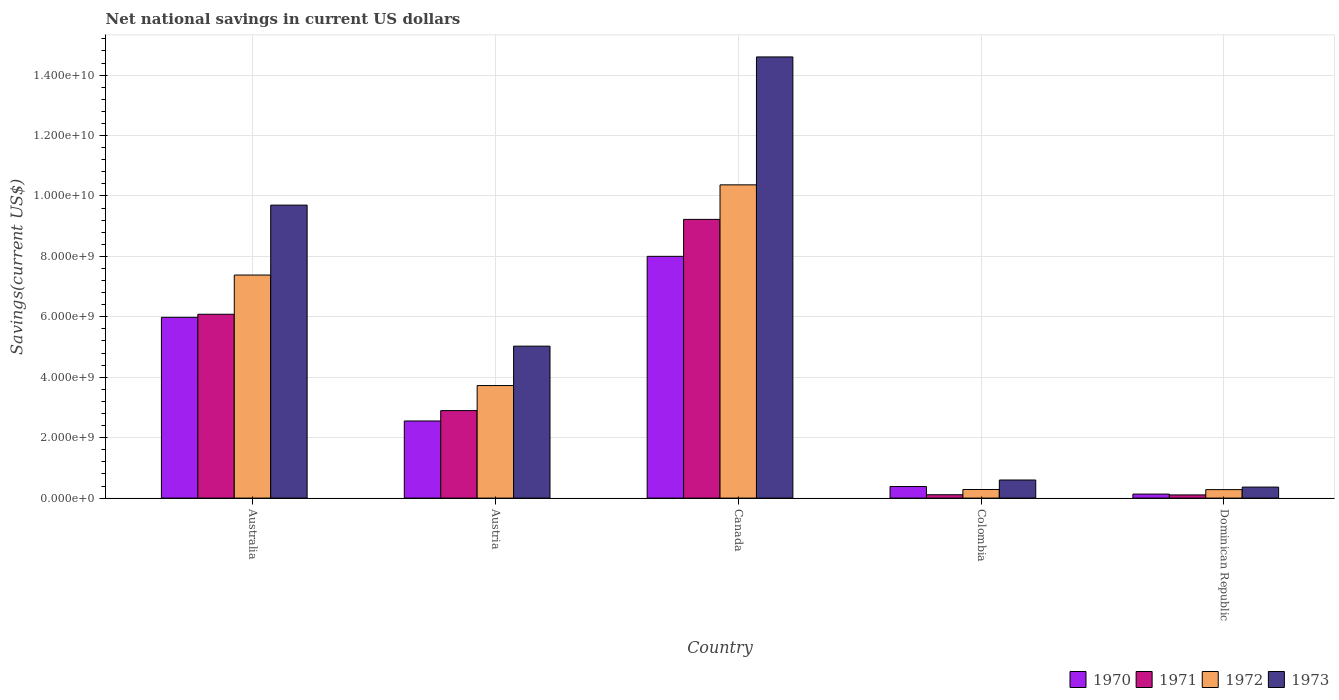How many bars are there on the 1st tick from the right?
Offer a very short reply. 4. What is the label of the 5th group of bars from the left?
Provide a short and direct response. Dominican Republic. What is the net national savings in 1970 in Colombia?
Your answer should be very brief. 3.83e+08. Across all countries, what is the maximum net national savings in 1972?
Give a very brief answer. 1.04e+1. Across all countries, what is the minimum net national savings in 1972?
Keep it short and to the point. 2.80e+08. In which country was the net national savings in 1973 maximum?
Your answer should be compact. Canada. In which country was the net national savings in 1973 minimum?
Make the answer very short. Dominican Republic. What is the total net national savings in 1972 in the graph?
Provide a succinct answer. 2.20e+1. What is the difference between the net national savings in 1971 in Austria and that in Colombia?
Provide a short and direct response. 2.78e+09. What is the difference between the net national savings in 1970 in Austria and the net national savings in 1973 in Dominican Republic?
Provide a succinct answer. 2.19e+09. What is the average net national savings in 1972 per country?
Your answer should be very brief. 4.41e+09. What is the difference between the net national savings of/in 1971 and net national savings of/in 1972 in Canada?
Your answer should be very brief. -1.14e+09. In how many countries, is the net national savings in 1973 greater than 1200000000 US$?
Ensure brevity in your answer.  3. What is the ratio of the net national savings in 1973 in Canada to that in Dominican Republic?
Offer a very short reply. 40.06. What is the difference between the highest and the second highest net national savings in 1971?
Make the answer very short. 3.19e+09. What is the difference between the highest and the lowest net national savings in 1972?
Your answer should be very brief. 1.01e+1. In how many countries, is the net national savings in 1971 greater than the average net national savings in 1971 taken over all countries?
Give a very brief answer. 2. What does the 4th bar from the left in Australia represents?
Your answer should be very brief. 1973. Is it the case that in every country, the sum of the net national savings in 1972 and net national savings in 1971 is greater than the net national savings in 1970?
Give a very brief answer. Yes. Are all the bars in the graph horizontal?
Offer a very short reply. No. How many countries are there in the graph?
Offer a terse response. 5. Does the graph contain any zero values?
Keep it short and to the point. No. What is the title of the graph?
Give a very brief answer. Net national savings in current US dollars. Does "2011" appear as one of the legend labels in the graph?
Ensure brevity in your answer.  No. What is the label or title of the Y-axis?
Provide a succinct answer. Savings(current US$). What is the Savings(current US$) in 1970 in Australia?
Offer a terse response. 5.98e+09. What is the Savings(current US$) in 1971 in Australia?
Your answer should be compact. 6.09e+09. What is the Savings(current US$) in 1972 in Australia?
Offer a terse response. 7.38e+09. What is the Savings(current US$) of 1973 in Australia?
Your answer should be very brief. 9.70e+09. What is the Savings(current US$) in 1970 in Austria?
Your response must be concise. 2.55e+09. What is the Savings(current US$) of 1971 in Austria?
Provide a short and direct response. 2.90e+09. What is the Savings(current US$) of 1972 in Austria?
Offer a very short reply. 3.73e+09. What is the Savings(current US$) in 1973 in Austria?
Provide a short and direct response. 5.03e+09. What is the Savings(current US$) of 1970 in Canada?
Give a very brief answer. 8.00e+09. What is the Savings(current US$) in 1971 in Canada?
Provide a short and direct response. 9.23e+09. What is the Savings(current US$) in 1972 in Canada?
Provide a succinct answer. 1.04e+1. What is the Savings(current US$) of 1973 in Canada?
Give a very brief answer. 1.46e+1. What is the Savings(current US$) in 1970 in Colombia?
Your response must be concise. 3.83e+08. What is the Savings(current US$) of 1971 in Colombia?
Offer a terse response. 1.11e+08. What is the Savings(current US$) in 1972 in Colombia?
Your answer should be very brief. 2.84e+08. What is the Savings(current US$) of 1973 in Colombia?
Give a very brief answer. 5.98e+08. What is the Savings(current US$) in 1970 in Dominican Republic?
Your answer should be compact. 1.33e+08. What is the Savings(current US$) in 1971 in Dominican Republic?
Provide a succinct answer. 1.05e+08. What is the Savings(current US$) of 1972 in Dominican Republic?
Your response must be concise. 2.80e+08. What is the Savings(current US$) of 1973 in Dominican Republic?
Your answer should be compact. 3.65e+08. Across all countries, what is the maximum Savings(current US$) in 1970?
Keep it short and to the point. 8.00e+09. Across all countries, what is the maximum Savings(current US$) in 1971?
Give a very brief answer. 9.23e+09. Across all countries, what is the maximum Savings(current US$) in 1972?
Ensure brevity in your answer.  1.04e+1. Across all countries, what is the maximum Savings(current US$) in 1973?
Your response must be concise. 1.46e+1. Across all countries, what is the minimum Savings(current US$) in 1970?
Offer a very short reply. 1.33e+08. Across all countries, what is the minimum Savings(current US$) in 1971?
Your response must be concise. 1.05e+08. Across all countries, what is the minimum Savings(current US$) of 1972?
Offer a very short reply. 2.80e+08. Across all countries, what is the minimum Savings(current US$) in 1973?
Offer a very short reply. 3.65e+08. What is the total Savings(current US$) in 1970 in the graph?
Offer a terse response. 1.71e+1. What is the total Savings(current US$) of 1971 in the graph?
Give a very brief answer. 1.84e+1. What is the total Savings(current US$) of 1972 in the graph?
Provide a short and direct response. 2.20e+1. What is the total Savings(current US$) in 1973 in the graph?
Your response must be concise. 3.03e+1. What is the difference between the Savings(current US$) in 1970 in Australia and that in Austria?
Provide a succinct answer. 3.43e+09. What is the difference between the Savings(current US$) of 1971 in Australia and that in Austria?
Give a very brief answer. 3.19e+09. What is the difference between the Savings(current US$) in 1972 in Australia and that in Austria?
Your answer should be compact. 3.66e+09. What is the difference between the Savings(current US$) in 1973 in Australia and that in Austria?
Offer a very short reply. 4.67e+09. What is the difference between the Savings(current US$) in 1970 in Australia and that in Canada?
Make the answer very short. -2.02e+09. What is the difference between the Savings(current US$) of 1971 in Australia and that in Canada?
Ensure brevity in your answer.  -3.14e+09. What is the difference between the Savings(current US$) in 1972 in Australia and that in Canada?
Offer a very short reply. -2.99e+09. What is the difference between the Savings(current US$) in 1973 in Australia and that in Canada?
Give a very brief answer. -4.90e+09. What is the difference between the Savings(current US$) of 1970 in Australia and that in Colombia?
Offer a very short reply. 5.60e+09. What is the difference between the Savings(current US$) of 1971 in Australia and that in Colombia?
Your response must be concise. 5.97e+09. What is the difference between the Savings(current US$) in 1972 in Australia and that in Colombia?
Make the answer very short. 7.10e+09. What is the difference between the Savings(current US$) of 1973 in Australia and that in Colombia?
Provide a succinct answer. 9.10e+09. What is the difference between the Savings(current US$) in 1970 in Australia and that in Dominican Republic?
Provide a short and direct response. 5.85e+09. What is the difference between the Savings(current US$) of 1971 in Australia and that in Dominican Republic?
Provide a short and direct response. 5.98e+09. What is the difference between the Savings(current US$) of 1972 in Australia and that in Dominican Republic?
Provide a succinct answer. 7.10e+09. What is the difference between the Savings(current US$) in 1973 in Australia and that in Dominican Republic?
Offer a very short reply. 9.33e+09. What is the difference between the Savings(current US$) of 1970 in Austria and that in Canada?
Offer a terse response. -5.45e+09. What is the difference between the Savings(current US$) of 1971 in Austria and that in Canada?
Your answer should be compact. -6.33e+09. What is the difference between the Savings(current US$) of 1972 in Austria and that in Canada?
Provide a succinct answer. -6.64e+09. What is the difference between the Savings(current US$) of 1973 in Austria and that in Canada?
Ensure brevity in your answer.  -9.57e+09. What is the difference between the Savings(current US$) of 1970 in Austria and that in Colombia?
Make the answer very short. 2.17e+09. What is the difference between the Savings(current US$) in 1971 in Austria and that in Colombia?
Provide a succinct answer. 2.78e+09. What is the difference between the Savings(current US$) of 1972 in Austria and that in Colombia?
Your response must be concise. 3.44e+09. What is the difference between the Savings(current US$) in 1973 in Austria and that in Colombia?
Your answer should be compact. 4.43e+09. What is the difference between the Savings(current US$) in 1970 in Austria and that in Dominican Republic?
Offer a very short reply. 2.42e+09. What is the difference between the Savings(current US$) in 1971 in Austria and that in Dominican Republic?
Ensure brevity in your answer.  2.79e+09. What is the difference between the Savings(current US$) of 1972 in Austria and that in Dominican Republic?
Your answer should be very brief. 3.44e+09. What is the difference between the Savings(current US$) of 1973 in Austria and that in Dominican Republic?
Ensure brevity in your answer.  4.66e+09. What is the difference between the Savings(current US$) of 1970 in Canada and that in Colombia?
Your response must be concise. 7.62e+09. What is the difference between the Savings(current US$) of 1971 in Canada and that in Colombia?
Provide a succinct answer. 9.11e+09. What is the difference between the Savings(current US$) in 1972 in Canada and that in Colombia?
Your answer should be compact. 1.01e+1. What is the difference between the Savings(current US$) of 1973 in Canada and that in Colombia?
Make the answer very short. 1.40e+1. What is the difference between the Savings(current US$) of 1970 in Canada and that in Dominican Republic?
Your answer should be compact. 7.87e+09. What is the difference between the Savings(current US$) in 1971 in Canada and that in Dominican Republic?
Provide a succinct answer. 9.12e+09. What is the difference between the Savings(current US$) in 1972 in Canada and that in Dominican Republic?
Offer a terse response. 1.01e+1. What is the difference between the Savings(current US$) of 1973 in Canada and that in Dominican Republic?
Make the answer very short. 1.42e+1. What is the difference between the Savings(current US$) in 1970 in Colombia and that in Dominican Republic?
Offer a terse response. 2.50e+08. What is the difference between the Savings(current US$) of 1971 in Colombia and that in Dominican Republic?
Your answer should be compact. 6.03e+06. What is the difference between the Savings(current US$) of 1972 in Colombia and that in Dominican Republic?
Give a very brief answer. 3.48e+06. What is the difference between the Savings(current US$) of 1973 in Colombia and that in Dominican Republic?
Make the answer very short. 2.34e+08. What is the difference between the Savings(current US$) in 1970 in Australia and the Savings(current US$) in 1971 in Austria?
Offer a terse response. 3.09e+09. What is the difference between the Savings(current US$) of 1970 in Australia and the Savings(current US$) of 1972 in Austria?
Your response must be concise. 2.26e+09. What is the difference between the Savings(current US$) of 1970 in Australia and the Savings(current US$) of 1973 in Austria?
Give a very brief answer. 9.54e+08. What is the difference between the Savings(current US$) in 1971 in Australia and the Savings(current US$) in 1972 in Austria?
Your answer should be very brief. 2.36e+09. What is the difference between the Savings(current US$) of 1971 in Australia and the Savings(current US$) of 1973 in Austria?
Ensure brevity in your answer.  1.06e+09. What is the difference between the Savings(current US$) in 1972 in Australia and the Savings(current US$) in 1973 in Austria?
Your answer should be compact. 2.35e+09. What is the difference between the Savings(current US$) of 1970 in Australia and the Savings(current US$) of 1971 in Canada?
Your answer should be compact. -3.24e+09. What is the difference between the Savings(current US$) in 1970 in Australia and the Savings(current US$) in 1972 in Canada?
Keep it short and to the point. -4.38e+09. What is the difference between the Savings(current US$) in 1970 in Australia and the Savings(current US$) in 1973 in Canada?
Ensure brevity in your answer.  -8.62e+09. What is the difference between the Savings(current US$) of 1971 in Australia and the Savings(current US$) of 1972 in Canada?
Provide a short and direct response. -4.28e+09. What is the difference between the Savings(current US$) in 1971 in Australia and the Savings(current US$) in 1973 in Canada?
Your answer should be very brief. -8.52e+09. What is the difference between the Savings(current US$) of 1972 in Australia and the Savings(current US$) of 1973 in Canada?
Your answer should be very brief. -7.22e+09. What is the difference between the Savings(current US$) of 1970 in Australia and the Savings(current US$) of 1971 in Colombia?
Keep it short and to the point. 5.87e+09. What is the difference between the Savings(current US$) in 1970 in Australia and the Savings(current US$) in 1972 in Colombia?
Offer a very short reply. 5.70e+09. What is the difference between the Savings(current US$) of 1970 in Australia and the Savings(current US$) of 1973 in Colombia?
Provide a short and direct response. 5.38e+09. What is the difference between the Savings(current US$) of 1971 in Australia and the Savings(current US$) of 1972 in Colombia?
Keep it short and to the point. 5.80e+09. What is the difference between the Savings(current US$) of 1971 in Australia and the Savings(current US$) of 1973 in Colombia?
Your answer should be very brief. 5.49e+09. What is the difference between the Savings(current US$) of 1972 in Australia and the Savings(current US$) of 1973 in Colombia?
Your response must be concise. 6.78e+09. What is the difference between the Savings(current US$) in 1970 in Australia and the Savings(current US$) in 1971 in Dominican Republic?
Provide a short and direct response. 5.88e+09. What is the difference between the Savings(current US$) in 1970 in Australia and the Savings(current US$) in 1972 in Dominican Republic?
Provide a succinct answer. 5.70e+09. What is the difference between the Savings(current US$) in 1970 in Australia and the Savings(current US$) in 1973 in Dominican Republic?
Keep it short and to the point. 5.62e+09. What is the difference between the Savings(current US$) in 1971 in Australia and the Savings(current US$) in 1972 in Dominican Republic?
Make the answer very short. 5.80e+09. What is the difference between the Savings(current US$) in 1971 in Australia and the Savings(current US$) in 1973 in Dominican Republic?
Your response must be concise. 5.72e+09. What is the difference between the Savings(current US$) of 1972 in Australia and the Savings(current US$) of 1973 in Dominican Republic?
Provide a succinct answer. 7.02e+09. What is the difference between the Savings(current US$) of 1970 in Austria and the Savings(current US$) of 1971 in Canada?
Your answer should be compact. -6.67e+09. What is the difference between the Savings(current US$) of 1970 in Austria and the Savings(current US$) of 1972 in Canada?
Give a very brief answer. -7.82e+09. What is the difference between the Savings(current US$) of 1970 in Austria and the Savings(current US$) of 1973 in Canada?
Provide a short and direct response. -1.20e+1. What is the difference between the Savings(current US$) of 1971 in Austria and the Savings(current US$) of 1972 in Canada?
Provide a short and direct response. -7.47e+09. What is the difference between the Savings(current US$) of 1971 in Austria and the Savings(current US$) of 1973 in Canada?
Make the answer very short. -1.17e+1. What is the difference between the Savings(current US$) in 1972 in Austria and the Savings(current US$) in 1973 in Canada?
Your answer should be compact. -1.09e+1. What is the difference between the Savings(current US$) of 1970 in Austria and the Savings(current US$) of 1971 in Colombia?
Make the answer very short. 2.44e+09. What is the difference between the Savings(current US$) of 1970 in Austria and the Savings(current US$) of 1972 in Colombia?
Your response must be concise. 2.27e+09. What is the difference between the Savings(current US$) of 1970 in Austria and the Savings(current US$) of 1973 in Colombia?
Ensure brevity in your answer.  1.95e+09. What is the difference between the Savings(current US$) of 1971 in Austria and the Savings(current US$) of 1972 in Colombia?
Your answer should be compact. 2.61e+09. What is the difference between the Savings(current US$) of 1971 in Austria and the Savings(current US$) of 1973 in Colombia?
Provide a short and direct response. 2.30e+09. What is the difference between the Savings(current US$) of 1972 in Austria and the Savings(current US$) of 1973 in Colombia?
Give a very brief answer. 3.13e+09. What is the difference between the Savings(current US$) of 1970 in Austria and the Savings(current US$) of 1971 in Dominican Republic?
Keep it short and to the point. 2.45e+09. What is the difference between the Savings(current US$) in 1970 in Austria and the Savings(current US$) in 1972 in Dominican Republic?
Ensure brevity in your answer.  2.27e+09. What is the difference between the Savings(current US$) in 1970 in Austria and the Savings(current US$) in 1973 in Dominican Republic?
Ensure brevity in your answer.  2.19e+09. What is the difference between the Savings(current US$) of 1971 in Austria and the Savings(current US$) of 1972 in Dominican Republic?
Your response must be concise. 2.62e+09. What is the difference between the Savings(current US$) of 1971 in Austria and the Savings(current US$) of 1973 in Dominican Republic?
Give a very brief answer. 2.53e+09. What is the difference between the Savings(current US$) of 1972 in Austria and the Savings(current US$) of 1973 in Dominican Republic?
Give a very brief answer. 3.36e+09. What is the difference between the Savings(current US$) in 1970 in Canada and the Savings(current US$) in 1971 in Colombia?
Offer a very short reply. 7.89e+09. What is the difference between the Savings(current US$) in 1970 in Canada and the Savings(current US$) in 1972 in Colombia?
Offer a very short reply. 7.72e+09. What is the difference between the Savings(current US$) of 1970 in Canada and the Savings(current US$) of 1973 in Colombia?
Your answer should be compact. 7.40e+09. What is the difference between the Savings(current US$) in 1971 in Canada and the Savings(current US$) in 1972 in Colombia?
Offer a terse response. 8.94e+09. What is the difference between the Savings(current US$) of 1971 in Canada and the Savings(current US$) of 1973 in Colombia?
Offer a very short reply. 8.63e+09. What is the difference between the Savings(current US$) in 1972 in Canada and the Savings(current US$) in 1973 in Colombia?
Provide a short and direct response. 9.77e+09. What is the difference between the Savings(current US$) in 1970 in Canada and the Savings(current US$) in 1971 in Dominican Republic?
Make the answer very short. 7.90e+09. What is the difference between the Savings(current US$) in 1970 in Canada and the Savings(current US$) in 1972 in Dominican Republic?
Your response must be concise. 7.72e+09. What is the difference between the Savings(current US$) of 1970 in Canada and the Savings(current US$) of 1973 in Dominican Republic?
Make the answer very short. 7.64e+09. What is the difference between the Savings(current US$) of 1971 in Canada and the Savings(current US$) of 1972 in Dominican Republic?
Give a very brief answer. 8.94e+09. What is the difference between the Savings(current US$) of 1971 in Canada and the Savings(current US$) of 1973 in Dominican Republic?
Give a very brief answer. 8.86e+09. What is the difference between the Savings(current US$) in 1972 in Canada and the Savings(current US$) in 1973 in Dominican Republic?
Give a very brief answer. 1.00e+1. What is the difference between the Savings(current US$) in 1970 in Colombia and the Savings(current US$) in 1971 in Dominican Republic?
Ensure brevity in your answer.  2.77e+08. What is the difference between the Savings(current US$) in 1970 in Colombia and the Savings(current US$) in 1972 in Dominican Republic?
Give a very brief answer. 1.02e+08. What is the difference between the Savings(current US$) of 1970 in Colombia and the Savings(current US$) of 1973 in Dominican Republic?
Ensure brevity in your answer.  1.82e+07. What is the difference between the Savings(current US$) of 1971 in Colombia and the Savings(current US$) of 1972 in Dominican Republic?
Provide a succinct answer. -1.69e+08. What is the difference between the Savings(current US$) of 1971 in Colombia and the Savings(current US$) of 1973 in Dominican Republic?
Your answer should be very brief. -2.53e+08. What is the difference between the Savings(current US$) of 1972 in Colombia and the Savings(current US$) of 1973 in Dominican Republic?
Your response must be concise. -8.05e+07. What is the average Savings(current US$) of 1970 per country?
Offer a very short reply. 3.41e+09. What is the average Savings(current US$) of 1971 per country?
Give a very brief answer. 3.68e+09. What is the average Savings(current US$) of 1972 per country?
Give a very brief answer. 4.41e+09. What is the average Savings(current US$) in 1973 per country?
Provide a succinct answer. 6.06e+09. What is the difference between the Savings(current US$) in 1970 and Savings(current US$) in 1971 in Australia?
Make the answer very short. -1.02e+08. What is the difference between the Savings(current US$) in 1970 and Savings(current US$) in 1972 in Australia?
Offer a terse response. -1.40e+09. What is the difference between the Savings(current US$) in 1970 and Savings(current US$) in 1973 in Australia?
Your response must be concise. -3.71e+09. What is the difference between the Savings(current US$) in 1971 and Savings(current US$) in 1972 in Australia?
Give a very brief answer. -1.30e+09. What is the difference between the Savings(current US$) of 1971 and Savings(current US$) of 1973 in Australia?
Your answer should be compact. -3.61e+09. What is the difference between the Savings(current US$) in 1972 and Savings(current US$) in 1973 in Australia?
Your answer should be compact. -2.31e+09. What is the difference between the Savings(current US$) in 1970 and Savings(current US$) in 1971 in Austria?
Provide a succinct answer. -3.44e+08. What is the difference between the Savings(current US$) of 1970 and Savings(current US$) of 1972 in Austria?
Your response must be concise. -1.17e+09. What is the difference between the Savings(current US$) of 1970 and Savings(current US$) of 1973 in Austria?
Provide a succinct answer. -2.48e+09. What is the difference between the Savings(current US$) in 1971 and Savings(current US$) in 1972 in Austria?
Your answer should be compact. -8.29e+08. What is the difference between the Savings(current US$) of 1971 and Savings(current US$) of 1973 in Austria?
Keep it short and to the point. -2.13e+09. What is the difference between the Savings(current US$) in 1972 and Savings(current US$) in 1973 in Austria?
Ensure brevity in your answer.  -1.30e+09. What is the difference between the Savings(current US$) in 1970 and Savings(current US$) in 1971 in Canada?
Your answer should be compact. -1.22e+09. What is the difference between the Savings(current US$) in 1970 and Savings(current US$) in 1972 in Canada?
Offer a terse response. -2.37e+09. What is the difference between the Savings(current US$) in 1970 and Savings(current US$) in 1973 in Canada?
Make the answer very short. -6.60e+09. What is the difference between the Savings(current US$) in 1971 and Savings(current US$) in 1972 in Canada?
Ensure brevity in your answer.  -1.14e+09. What is the difference between the Savings(current US$) in 1971 and Savings(current US$) in 1973 in Canada?
Offer a very short reply. -5.38e+09. What is the difference between the Savings(current US$) in 1972 and Savings(current US$) in 1973 in Canada?
Your answer should be very brief. -4.23e+09. What is the difference between the Savings(current US$) in 1970 and Savings(current US$) in 1971 in Colombia?
Provide a short and direct response. 2.71e+08. What is the difference between the Savings(current US$) in 1970 and Savings(current US$) in 1972 in Colombia?
Offer a terse response. 9.87e+07. What is the difference between the Savings(current US$) of 1970 and Savings(current US$) of 1973 in Colombia?
Your response must be concise. -2.16e+08. What is the difference between the Savings(current US$) of 1971 and Savings(current US$) of 1972 in Colombia?
Give a very brief answer. -1.73e+08. What is the difference between the Savings(current US$) of 1971 and Savings(current US$) of 1973 in Colombia?
Give a very brief answer. -4.87e+08. What is the difference between the Savings(current US$) in 1972 and Savings(current US$) in 1973 in Colombia?
Ensure brevity in your answer.  -3.14e+08. What is the difference between the Savings(current US$) of 1970 and Savings(current US$) of 1971 in Dominican Republic?
Ensure brevity in your answer.  2.74e+07. What is the difference between the Savings(current US$) of 1970 and Savings(current US$) of 1972 in Dominican Republic?
Give a very brief answer. -1.48e+08. What is the difference between the Savings(current US$) of 1970 and Savings(current US$) of 1973 in Dominican Republic?
Keep it short and to the point. -2.32e+08. What is the difference between the Savings(current US$) in 1971 and Savings(current US$) in 1972 in Dominican Republic?
Offer a terse response. -1.75e+08. What is the difference between the Savings(current US$) in 1971 and Savings(current US$) in 1973 in Dominican Republic?
Your answer should be compact. -2.59e+08. What is the difference between the Savings(current US$) of 1972 and Savings(current US$) of 1973 in Dominican Republic?
Ensure brevity in your answer.  -8.40e+07. What is the ratio of the Savings(current US$) of 1970 in Australia to that in Austria?
Ensure brevity in your answer.  2.34. What is the ratio of the Savings(current US$) in 1971 in Australia to that in Austria?
Offer a terse response. 2.1. What is the ratio of the Savings(current US$) of 1972 in Australia to that in Austria?
Ensure brevity in your answer.  1.98. What is the ratio of the Savings(current US$) in 1973 in Australia to that in Austria?
Your response must be concise. 1.93. What is the ratio of the Savings(current US$) in 1970 in Australia to that in Canada?
Ensure brevity in your answer.  0.75. What is the ratio of the Savings(current US$) in 1971 in Australia to that in Canada?
Your answer should be compact. 0.66. What is the ratio of the Savings(current US$) of 1972 in Australia to that in Canada?
Provide a succinct answer. 0.71. What is the ratio of the Savings(current US$) of 1973 in Australia to that in Canada?
Your response must be concise. 0.66. What is the ratio of the Savings(current US$) of 1970 in Australia to that in Colombia?
Provide a short and direct response. 15.64. What is the ratio of the Savings(current US$) of 1971 in Australia to that in Colombia?
Make the answer very short. 54.61. What is the ratio of the Savings(current US$) of 1972 in Australia to that in Colombia?
Your response must be concise. 26. What is the ratio of the Savings(current US$) of 1973 in Australia to that in Colombia?
Offer a very short reply. 16.2. What is the ratio of the Savings(current US$) of 1970 in Australia to that in Dominican Republic?
Provide a succinct answer. 45.07. What is the ratio of the Savings(current US$) in 1971 in Australia to that in Dominican Republic?
Ensure brevity in your answer.  57.73. What is the ratio of the Savings(current US$) of 1972 in Australia to that in Dominican Republic?
Your answer should be compact. 26.32. What is the ratio of the Savings(current US$) in 1973 in Australia to that in Dominican Republic?
Your answer should be compact. 26.6. What is the ratio of the Savings(current US$) of 1970 in Austria to that in Canada?
Give a very brief answer. 0.32. What is the ratio of the Savings(current US$) of 1971 in Austria to that in Canada?
Offer a terse response. 0.31. What is the ratio of the Savings(current US$) in 1972 in Austria to that in Canada?
Provide a succinct answer. 0.36. What is the ratio of the Savings(current US$) of 1973 in Austria to that in Canada?
Offer a terse response. 0.34. What is the ratio of the Savings(current US$) of 1970 in Austria to that in Colombia?
Your response must be concise. 6.67. What is the ratio of the Savings(current US$) in 1971 in Austria to that in Colombia?
Ensure brevity in your answer.  25.99. What is the ratio of the Savings(current US$) in 1972 in Austria to that in Colombia?
Give a very brief answer. 13.12. What is the ratio of the Savings(current US$) of 1973 in Austria to that in Colombia?
Provide a succinct answer. 8.4. What is the ratio of the Savings(current US$) in 1970 in Austria to that in Dominican Republic?
Provide a succinct answer. 19.23. What is the ratio of the Savings(current US$) of 1971 in Austria to that in Dominican Republic?
Keep it short and to the point. 27.48. What is the ratio of the Savings(current US$) of 1972 in Austria to that in Dominican Republic?
Make the answer very short. 13.28. What is the ratio of the Savings(current US$) in 1973 in Austria to that in Dominican Republic?
Give a very brief answer. 13.8. What is the ratio of the Savings(current US$) in 1970 in Canada to that in Colombia?
Offer a terse response. 20.91. What is the ratio of the Savings(current US$) in 1971 in Canada to that in Colombia?
Keep it short and to the point. 82.79. What is the ratio of the Savings(current US$) in 1972 in Canada to that in Colombia?
Ensure brevity in your answer.  36.51. What is the ratio of the Savings(current US$) of 1973 in Canada to that in Colombia?
Your answer should be compact. 24.4. What is the ratio of the Savings(current US$) in 1970 in Canada to that in Dominican Republic?
Offer a terse response. 60.27. What is the ratio of the Savings(current US$) in 1971 in Canada to that in Dominican Republic?
Your response must be concise. 87.52. What is the ratio of the Savings(current US$) of 1972 in Canada to that in Dominican Republic?
Your response must be concise. 36.96. What is the ratio of the Savings(current US$) in 1973 in Canada to that in Dominican Republic?
Your response must be concise. 40.06. What is the ratio of the Savings(current US$) in 1970 in Colombia to that in Dominican Republic?
Make the answer very short. 2.88. What is the ratio of the Savings(current US$) of 1971 in Colombia to that in Dominican Republic?
Your answer should be compact. 1.06. What is the ratio of the Savings(current US$) of 1972 in Colombia to that in Dominican Republic?
Keep it short and to the point. 1.01. What is the ratio of the Savings(current US$) in 1973 in Colombia to that in Dominican Republic?
Give a very brief answer. 1.64. What is the difference between the highest and the second highest Savings(current US$) in 1970?
Your response must be concise. 2.02e+09. What is the difference between the highest and the second highest Savings(current US$) in 1971?
Make the answer very short. 3.14e+09. What is the difference between the highest and the second highest Savings(current US$) in 1972?
Your response must be concise. 2.99e+09. What is the difference between the highest and the second highest Savings(current US$) in 1973?
Offer a very short reply. 4.90e+09. What is the difference between the highest and the lowest Savings(current US$) in 1970?
Your answer should be very brief. 7.87e+09. What is the difference between the highest and the lowest Savings(current US$) of 1971?
Your answer should be compact. 9.12e+09. What is the difference between the highest and the lowest Savings(current US$) in 1972?
Offer a very short reply. 1.01e+1. What is the difference between the highest and the lowest Savings(current US$) of 1973?
Your response must be concise. 1.42e+1. 